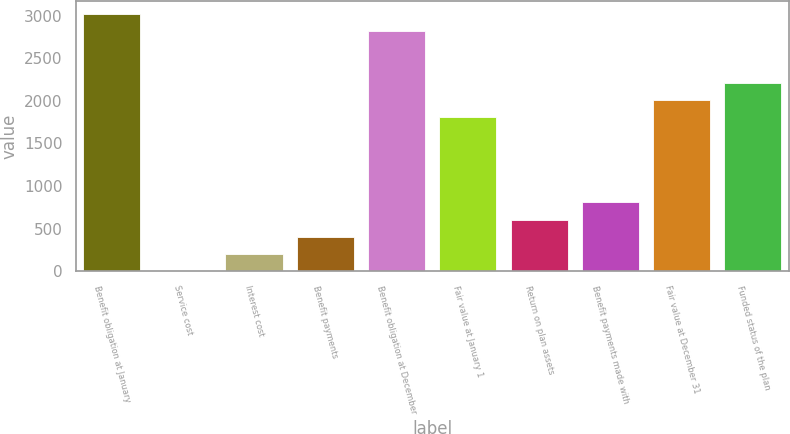Convert chart. <chart><loc_0><loc_0><loc_500><loc_500><bar_chart><fcel>Benefit obligation at January<fcel>Service cost<fcel>Interest cost<fcel>Benefit payments<fcel>Benefit obligation at December<fcel>Fair value at January 1<fcel>Return on plan assets<fcel>Benefit payments made with<fcel>Fair value at December 31<fcel>Funded status of the plan<nl><fcel>3016.5<fcel>3<fcel>203.9<fcel>404.8<fcel>2815.6<fcel>1811.1<fcel>605.7<fcel>806.6<fcel>2012<fcel>2212.9<nl></chart> 